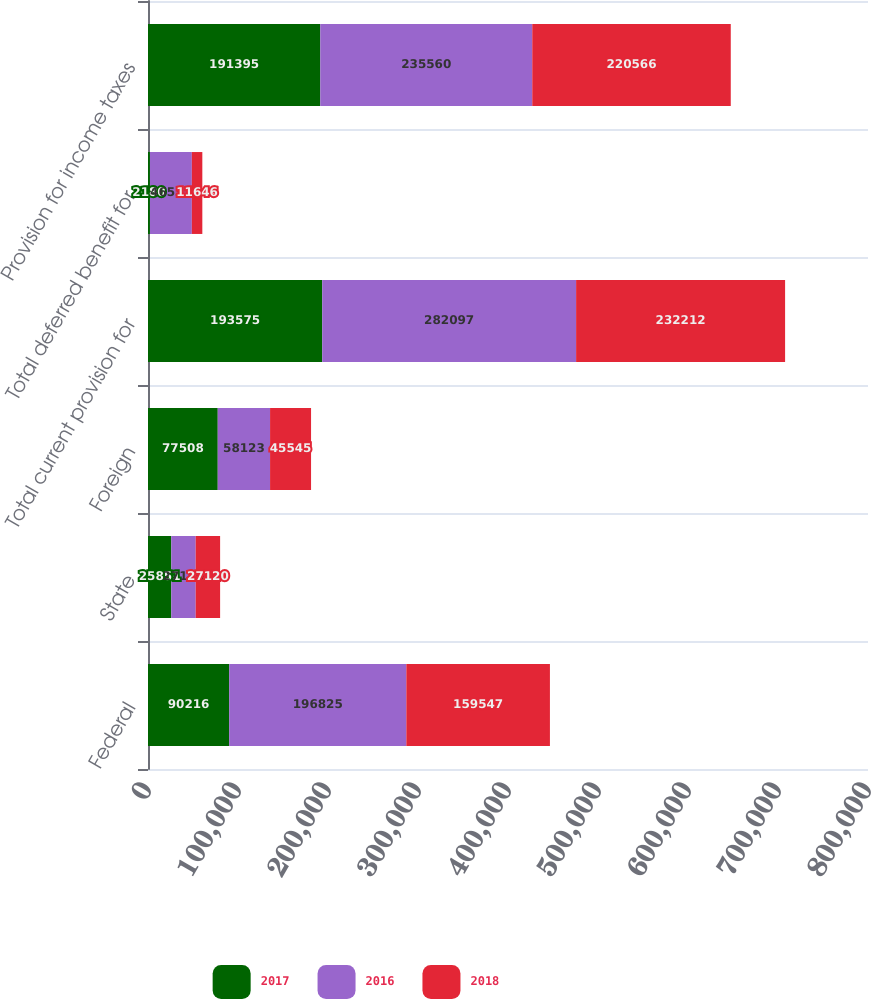Convert chart to OTSL. <chart><loc_0><loc_0><loc_500><loc_500><stacked_bar_chart><ecel><fcel>Federal<fcel>State<fcel>Foreign<fcel>Total current provision for<fcel>Total deferred benefit for<fcel>Provision for income taxes<nl><fcel>2017<fcel>90216<fcel>25851<fcel>77508<fcel>193575<fcel>2180<fcel>191395<nl><fcel>2016<fcel>196825<fcel>27149<fcel>58123<fcel>282097<fcel>46537<fcel>235560<nl><fcel>2018<fcel>159547<fcel>27120<fcel>45545<fcel>232212<fcel>11646<fcel>220566<nl></chart> 